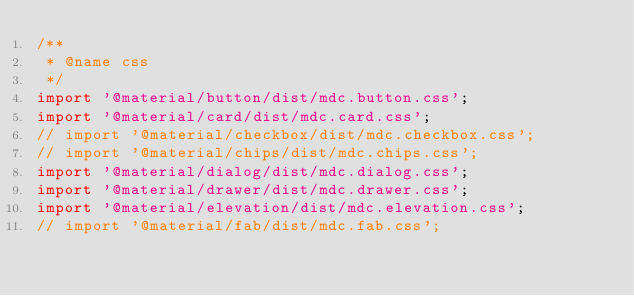Convert code to text. <code><loc_0><loc_0><loc_500><loc_500><_JavaScript_>/**
 * @name css
 */
import '@material/button/dist/mdc.button.css';
import '@material/card/dist/mdc.card.css';
// import '@material/checkbox/dist/mdc.checkbox.css';
// import '@material/chips/dist/mdc.chips.css';
import '@material/dialog/dist/mdc.dialog.css';
import '@material/drawer/dist/mdc.drawer.css';
import '@material/elevation/dist/mdc.elevation.css';
// import '@material/fab/dist/mdc.fab.css';</code> 